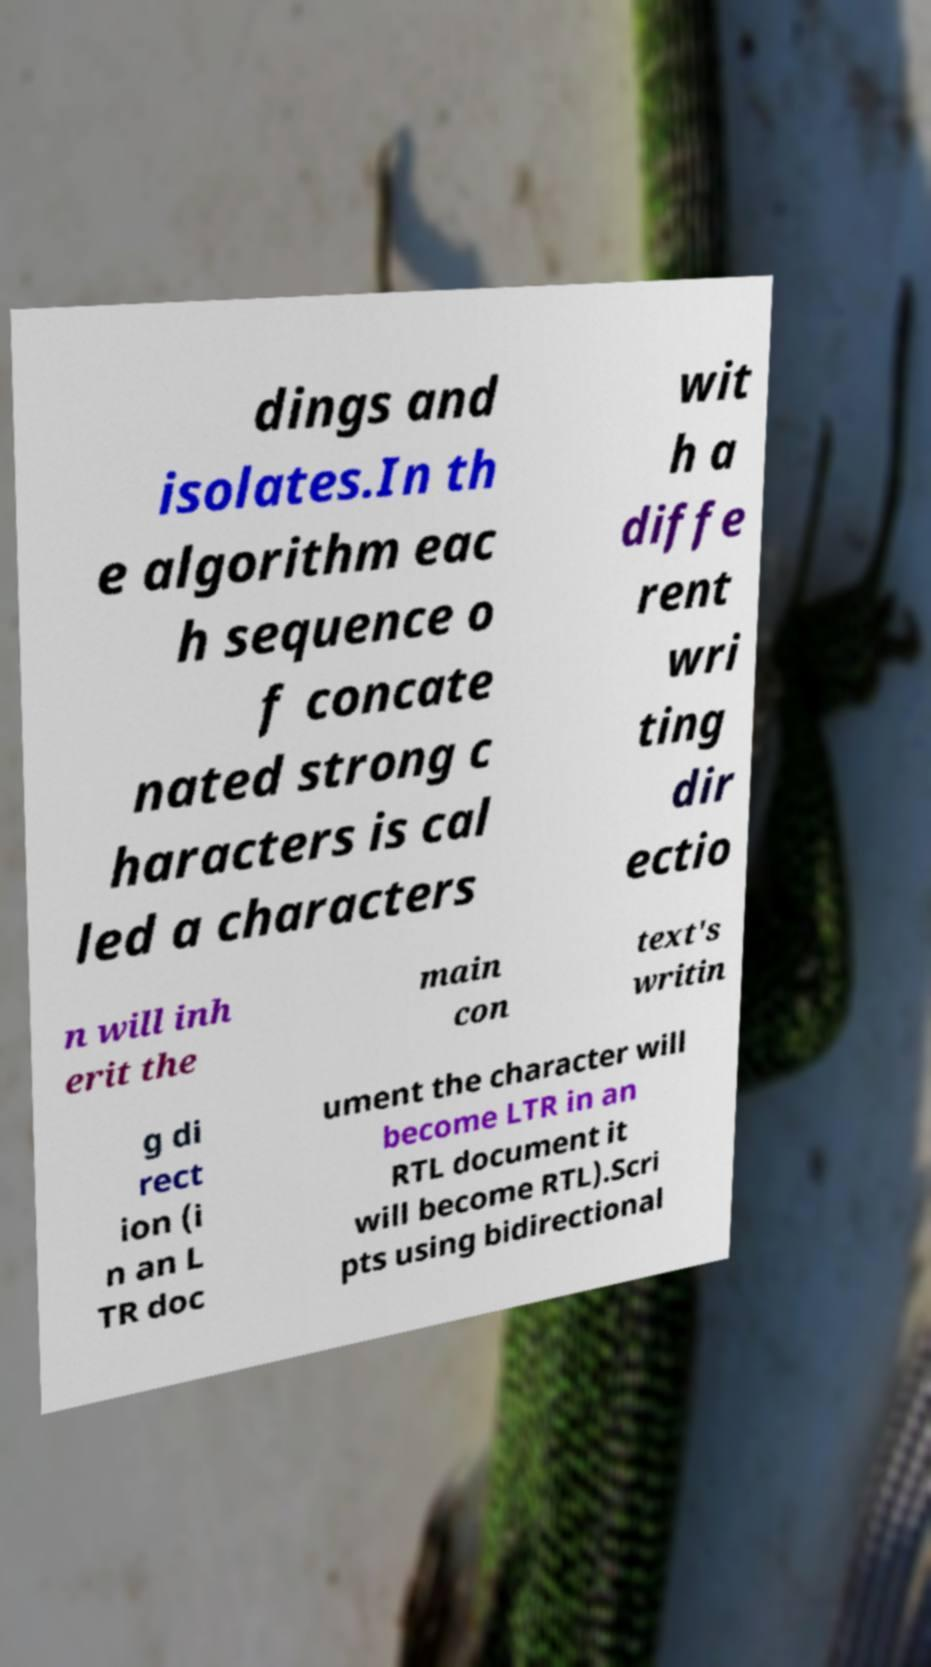Please read and relay the text visible in this image. What does it say? dings and isolates.In th e algorithm eac h sequence o f concate nated strong c haracters is cal led a characters wit h a diffe rent wri ting dir ectio n will inh erit the main con text's writin g di rect ion (i n an L TR doc ument the character will become LTR in an RTL document it will become RTL).Scri pts using bidirectional 